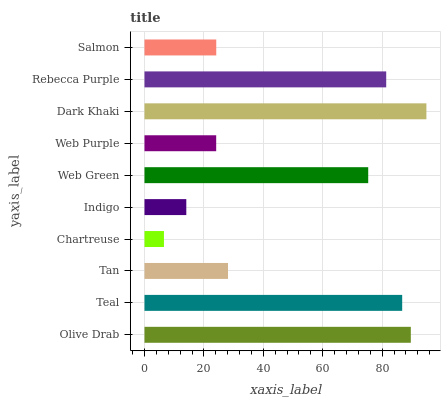Is Chartreuse the minimum?
Answer yes or no. Yes. Is Dark Khaki the maximum?
Answer yes or no. Yes. Is Teal the minimum?
Answer yes or no. No. Is Teal the maximum?
Answer yes or no. No. Is Olive Drab greater than Teal?
Answer yes or no. Yes. Is Teal less than Olive Drab?
Answer yes or no. Yes. Is Teal greater than Olive Drab?
Answer yes or no. No. Is Olive Drab less than Teal?
Answer yes or no. No. Is Web Green the high median?
Answer yes or no. Yes. Is Tan the low median?
Answer yes or no. Yes. Is Tan the high median?
Answer yes or no. No. Is Web Purple the low median?
Answer yes or no. No. 